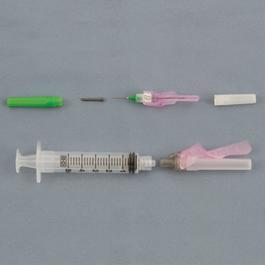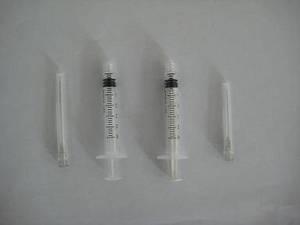The first image is the image on the left, the second image is the image on the right. For the images displayed, is the sentence "There are no more than two syringes." factually correct? Answer yes or no. No. The first image is the image on the left, the second image is the image on the right. Evaluate the accuracy of this statement regarding the images: "There is exactly one syringe in the right image.". Is it true? Answer yes or no. No. 